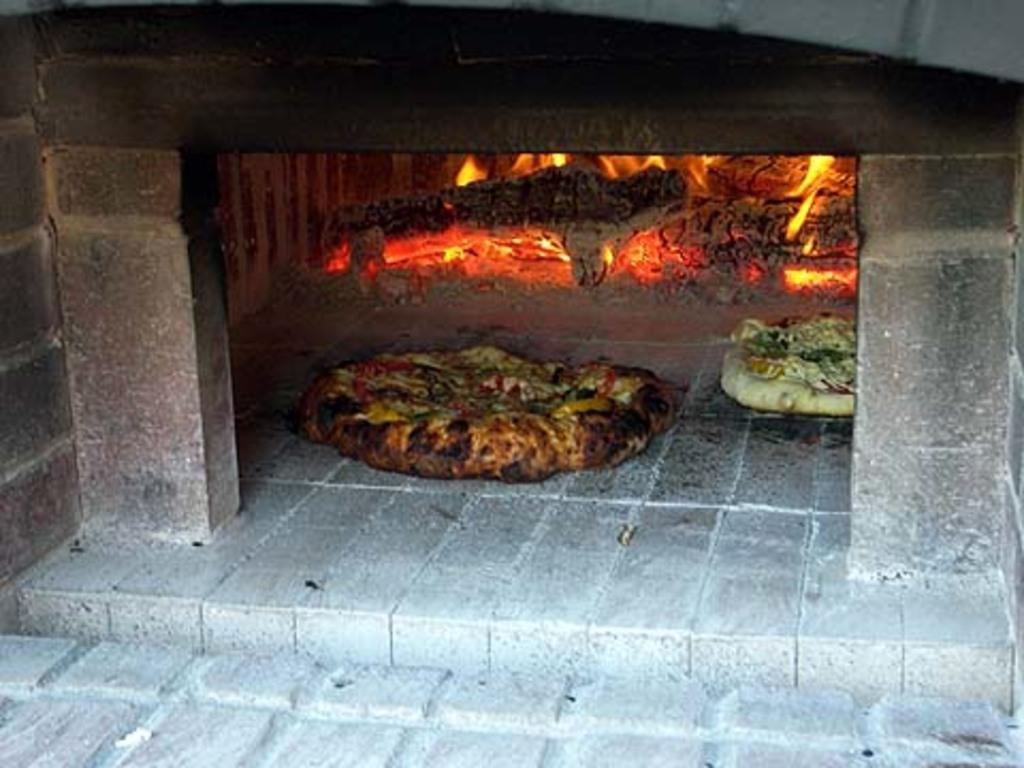Describe this image in one or two sentences. In the picture we can see a pizza oven with two pizzas inside it and behind it we can see the fire. 